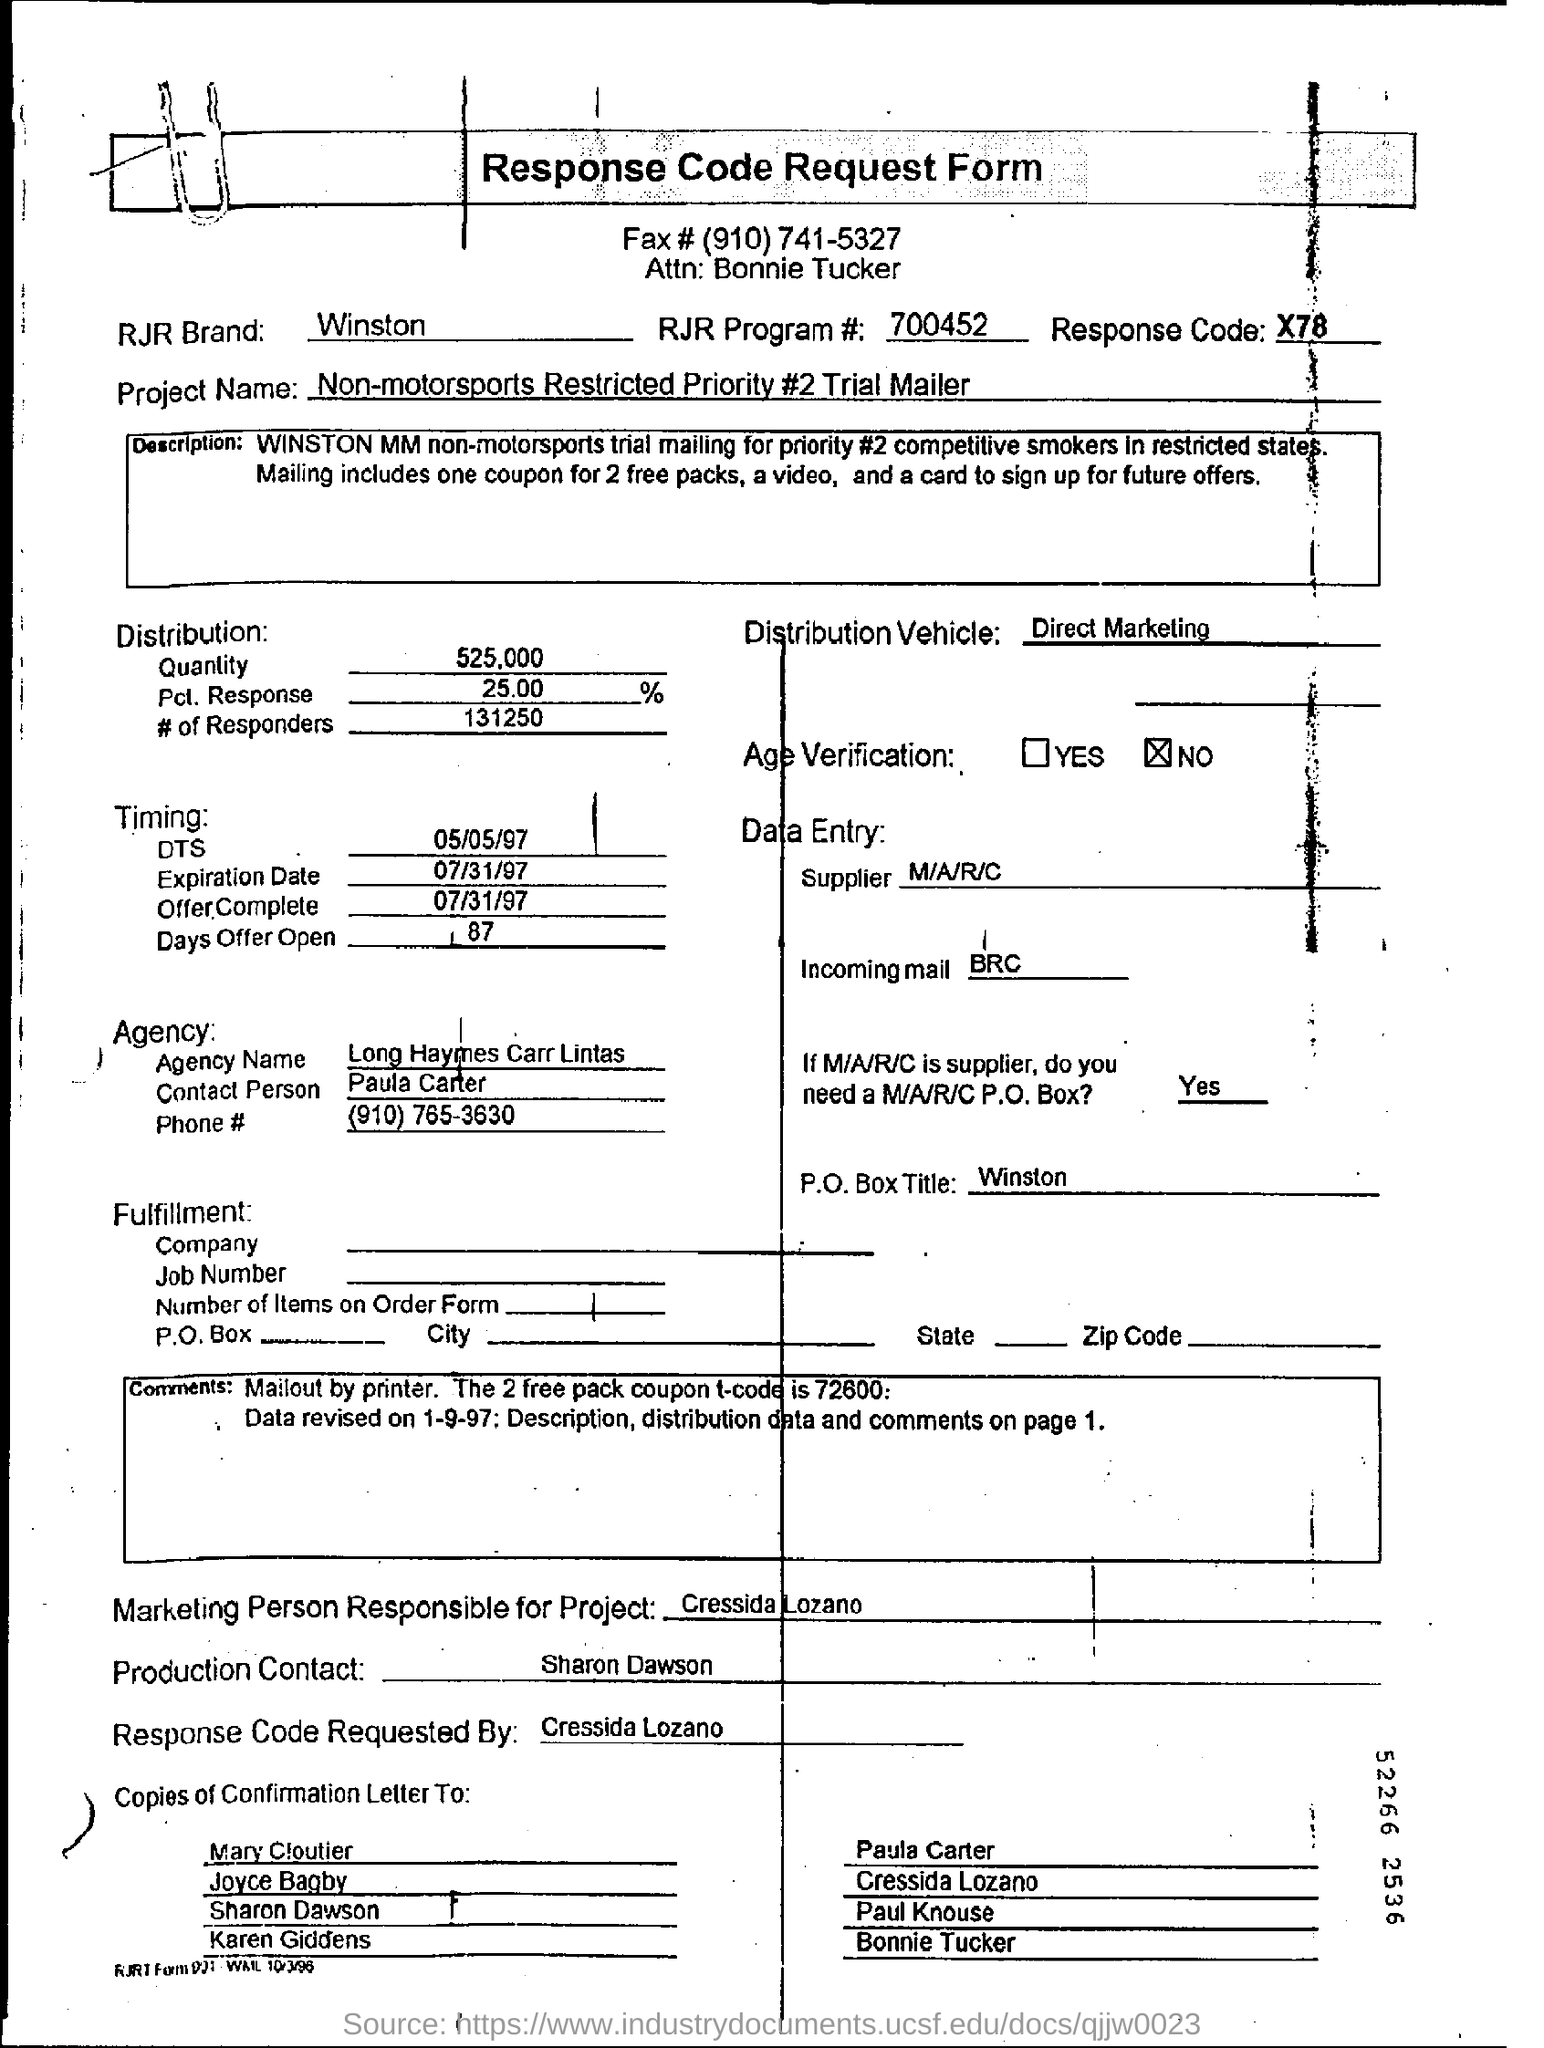What is the RJR Brand name?
Ensure brevity in your answer.  Winston. What is the Agency Name mentioned here?
Offer a very short reply. Long Haymes Carr Lintas. 